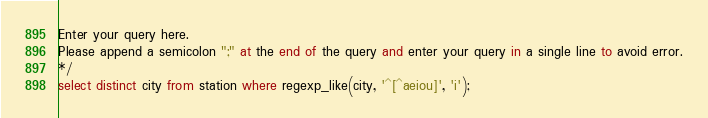Convert code to text. <code><loc_0><loc_0><loc_500><loc_500><_SQL_>Enter your query here.
Please append a semicolon ";" at the end of the query and enter your query in a single line to avoid error.
*/
select distinct city from station where regexp_like(city, '^[^aeiou]', 'i');
</code> 